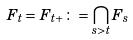Convert formula to latex. <formula><loc_0><loc_0><loc_500><loc_500>F _ { t } = F _ { t + } \colon = \bigcap _ { s > t } F _ { s }</formula> 